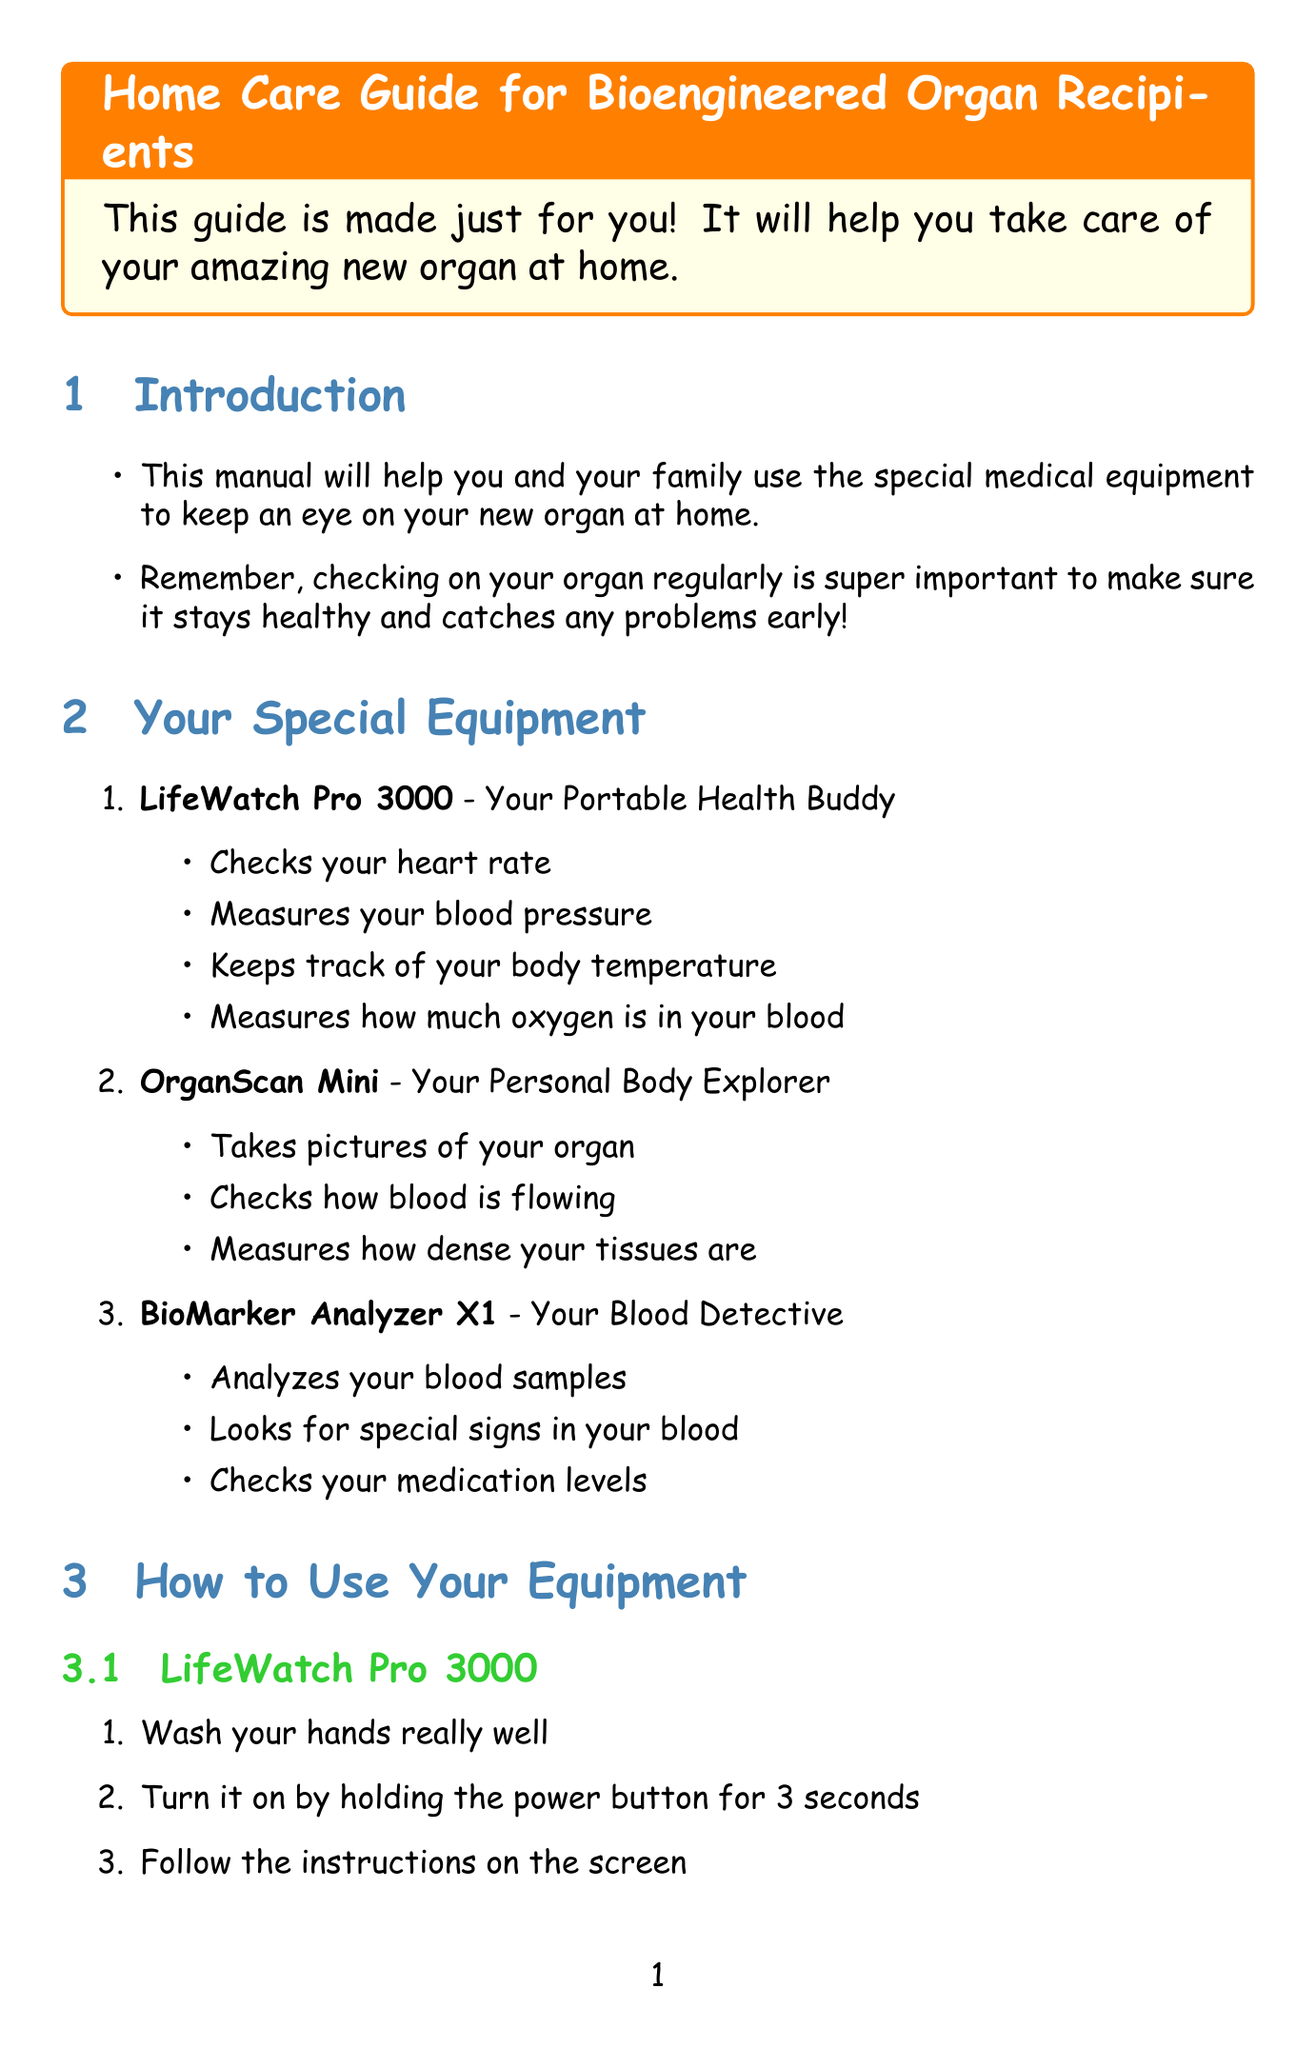What is the title of the manual? The title of the manual is mentioned at the beginning of the document.
Answer: Home Care Guide for Bioengineered Organ Recipients: Monitoring and Maintenance Who is the manufacturer of the LifeWatch Pro 3000? The document includes a list of equipment with their manufacturers.
Answer: MedTech Solutions What should you do if the device won't turn on? The troubleshooting section provides solutions for different device issues.
Answer: Check if the battery is charged How often should software updates be performed? The maintenance guidelines specify how frequently updates should occur.
Answer: Weekly What is one of the warning signs to contact your doctor? The emergency procedures outline warning signs for patients.
Answer: Persistent fever above 38°C (100.4°F) What device is used for blood sample analysis? The equipment list describes the main functions of each device, including their purposes.
Answer: BioMarker Analyzer X1 How should supplies like test strips be managed? The document provides clear instructions for inventory management of medical supplies.
Answer: Check supply levels and reorder if low What is the recommended action if unusual readings occur? The troubleshooting section suggests actions to take based on reading inconsistencies.
Answer: Verify that sensors are correctly placed and securely attached Which type of activity should be avoided according to the lifestyle considerations? The lifestyle considerations address specifics about activities to avoid.
Answer: Contact sports or activities with a high risk of injury to the transplant area 